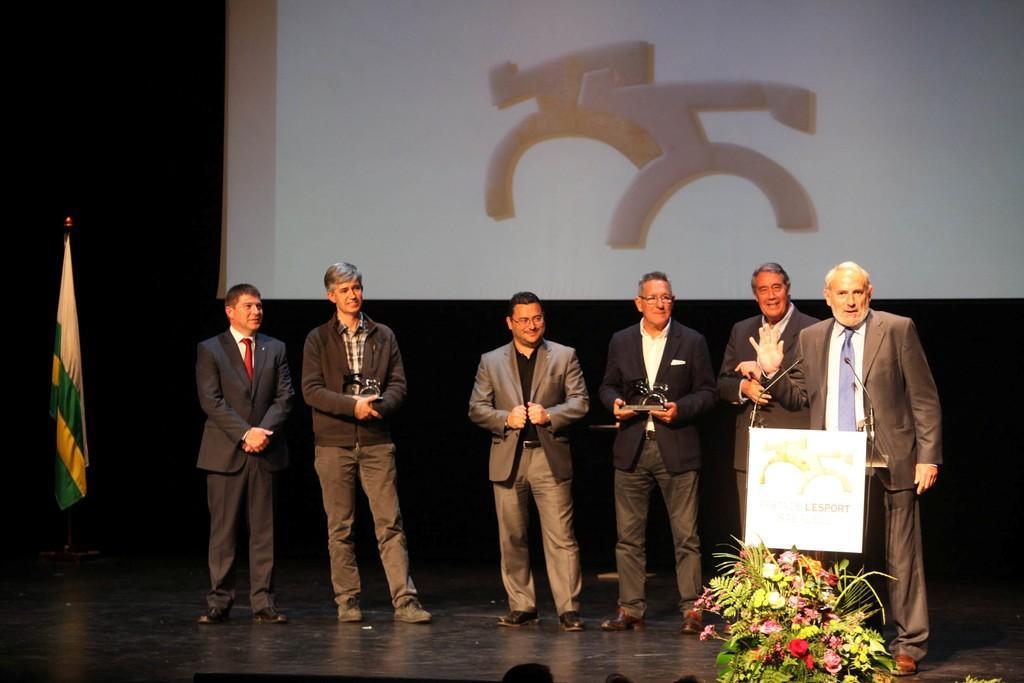Could you give a brief overview of what you see in this image? In this picture I can see 6 men standing in front and I see that 5 of them are wearing suits and the man on the right is standing in front of a podium and in the background I can see the projector screen and on the left side of this image, I can see a flag. On the bottom right of this picture I can see a bouquet. 